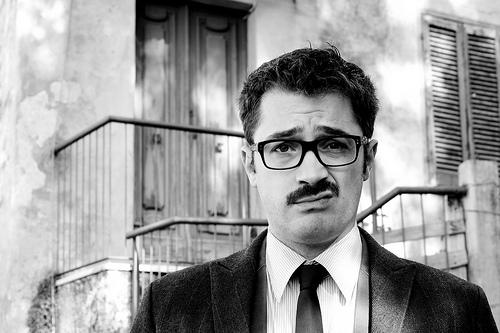Describe the man's hairstyle, including its color and any distinct features. The man's hairstyle is dark and short, with strands of hair sticking up and a distinguished line in the forehead. Which part of the man's clothing is white? Where is it positioned? The man is wearing a white button-up shirt, positioned under his suit jacket and around his neck area. Comment on the architectural features of the building in the image. The building has wooden window shutters with shutters over the windows, and wooden doors with metal railings behind the person. List three main aspects of the man's outfit and their locations. The man is wearing black glasses on his face, a black tie hanging down from his neck, and a white button-up shirt under his suit. Mention the type of photo and what does the man's expression seem like? The image is a black and white photo, and the man appears to be quite serious and somewhat concerned. How does the subject feel, and what are they wearing? The subject seems serious, concerned, and appears to be deep in thought. He is wearing a suit, black tie, glasses, and has a mustache. What is the most notable feature on the man's face? The man's most notable facial feature is his black mustache. State three facial features of the man in the image, including their colors and sizes. The man has black glasses, a black mustache, and his eyes are visible, but their specific sizes are not mentioned in the image. 